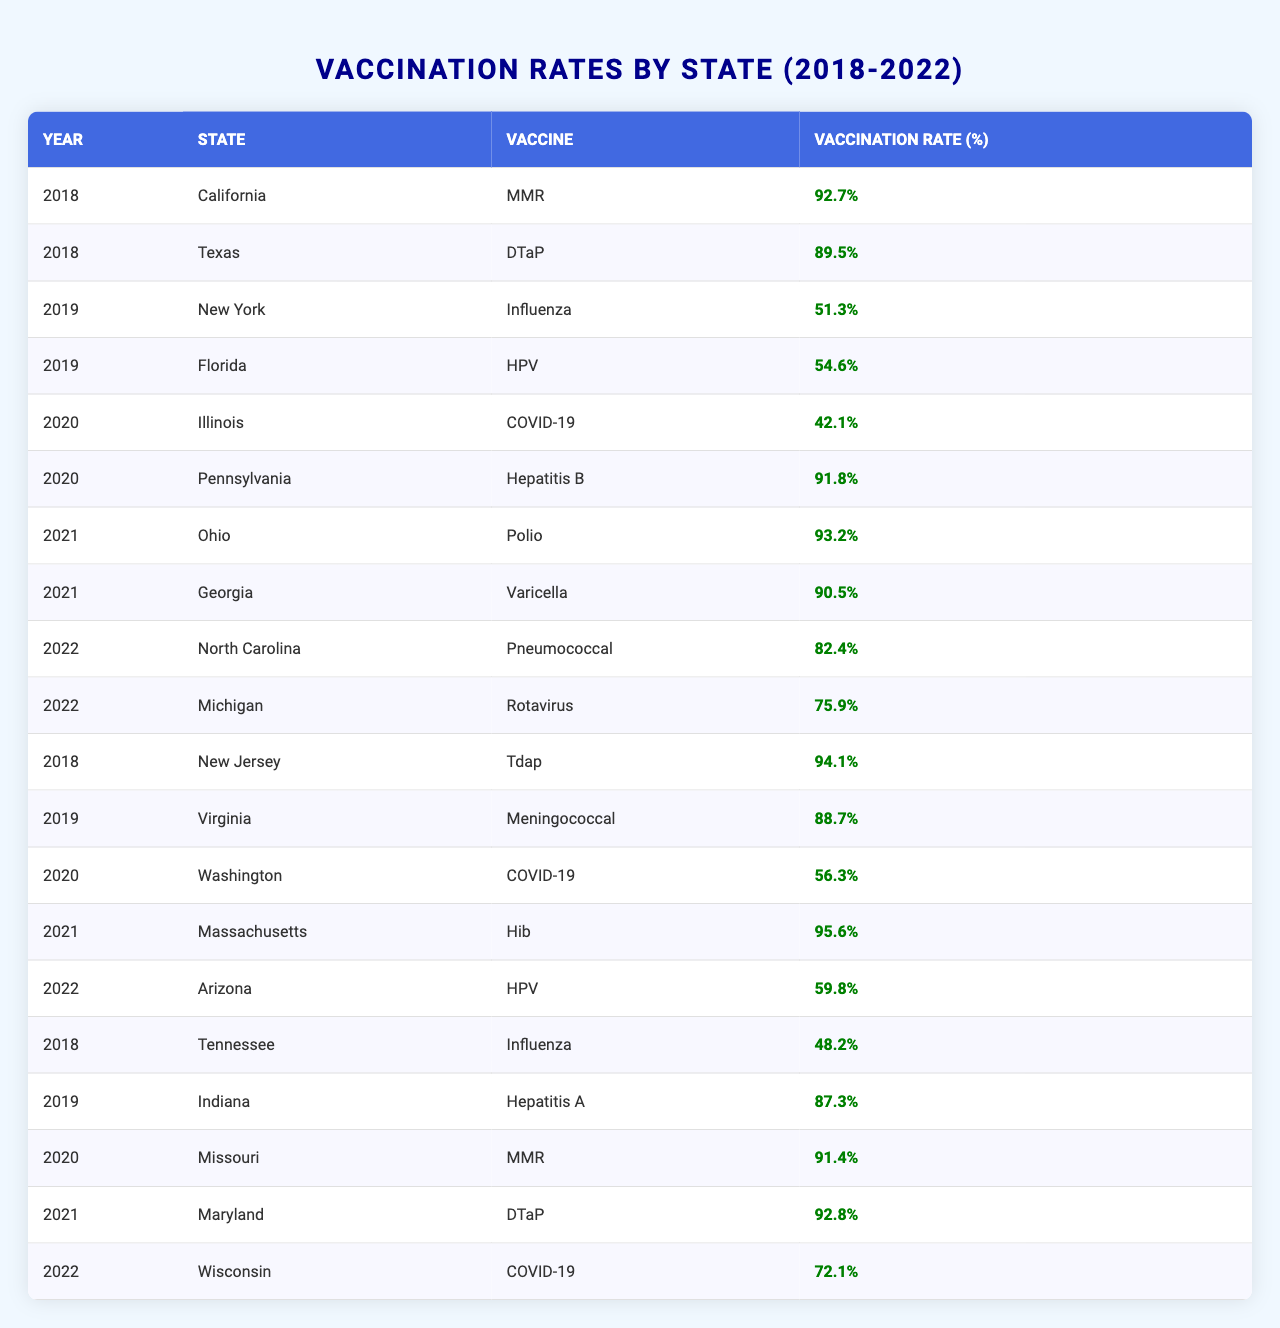What was the highest vaccination rate recorded for MMR? Searching through the table, I find that California had a vaccination rate of 92.7% for MMR in 2018, which is the highest value listed for this vaccine.
Answer: 92.7% In which year did Florida report the HPV vaccination rate? The data indicates that Florida reported the HPV vaccination rate in 2019, showing a vaccination rate of 54.6%.
Answer: 2019 Which state had the lowest vaccination rate in 2020? Looking at the data for 2020, Illinois had a vaccination rate of 42.1% for COVID-19, which is the lowest among all entries for that year.
Answer: Illinois What was the average vaccination rate for DTaP across the reported years? The DTaP vaccination rates are 89.5% in Texas (2018) and 92.8% in Maryland (2021). The average is calculated as (89.5 + 92.8) / 2 = 91.15%.
Answer: 91.15% Did any state report a vaccination rate above 95% for any vaccine? Yes, Massachusetts reported a DTaP vaccination rate of 95.6% in 2021, which is above 95%.
Answer: Yes Which state showed an increase in vaccination rate for COVID-19 from 2020 to 2021? From the table, Washington had a COVID-19 rate of 56.3% in 2020, and by 2021, there was data for Illinois at 42.1%. There is no increase based on the available data—both years show different states with varying rates. Hence, no direct increase for the same state is observed.
Answer: No Calculate the median vaccination rate for all reports in 2022. The vaccination rates for 2022 are 82.4% (North Carolina), 75.9% (Michigan), and 59.8% (Arizona). Sorting these values gives us 59.8%, 75.9%, 82.4%. The median, being the middle value, is 75.9%.
Answer: 75.9% What percentage of vaccination rates for Influenza is lower than the rate of California’s MMR? The table states that the rate for California's MMR is 92.7%. The only Influenza rate reported is Tennessee at 48.2%, which is lower. Thus only one case of Influenza is lower.
Answer: 1 What percentage of reported states had vaccination rates below 60% in 2022? For 2022, there are three states reported: North Carolina (82.4%), Michigan (75.9%), and Arizona (59.8%). Only Arizona is below 60%. That is 1 out of 3 states, which is approximately 33%.
Answer: 33% Which vaccine had the highest vaccination rate in 2021 among the states? In 2021, Massachusetts had the highest rate of 95.6% for Hib, making it the highest among all vaccines reported for that year.
Answer: Hib Was the vaccination rate for Hepatitis B in Pennsylvania lower than the average rate across all reported states for 2019? The Hepatitis B vaccination rate in Pennsylvania for 2020 is 91.8%. In 2019, the Hepatitis A rate in Indiana was 87.3%, Meningococcal in Virginia was 88.7%, Influenza in New York was 51.3%, and HPV in Florida was 54.6%. The average for 2019 (51.3 + 54.6 + 87.3 + 88.7) / 4 = 70.5% is lower than 91.8%. Thus, the statement is true.
Answer: Yes 